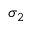Convert formula to latex. <formula><loc_0><loc_0><loc_500><loc_500>\sigma _ { 2 }</formula> 